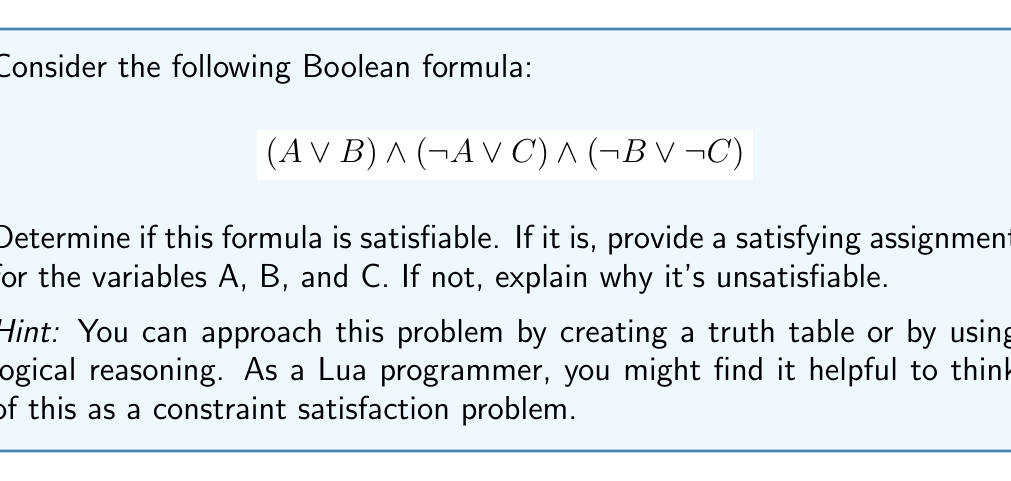Solve this math problem. Let's approach this step-by-step:

1) First, let's break down the formula into its constituent clauses:
   - Clause 1: $(A \lor B)$
   - Clause 2: $(\neg A \lor C)$
   - Clause 3: $(\neg B \lor \neg C)$

2) For the formula to be satisfiable, all these clauses must be true simultaneously.

3) Let's start with Clause 1: $(A \lor B)$
   - This means either A or B (or both) must be true.

4) Now, let's look at Clause 2: $(\neg A \lor C)$
   - This means either A must be false or C must be true (or both).

5) Clause 3: $(\neg B \lor \neg C)$
   - This means either B must be false or C must be false (or both).

6) Let's try to find a satisfying assignment:
   - If we set A = true, then from Clause 2, C must be true.
   - But if C is true, then from Clause 3, B must be false.
   - This assignment (A = true, B = false, C = true) satisfies all clauses.

7) We can verify:
   - $(A \lor B)$ is true because A is true.
   - $(\neg A \lor C)$ is true because C is true.
   - $(\neg B \lor \neg C)$ is true because B is false.

8) Therefore, the formula is satisfiable.

In Lua, you might represent this as:

```lua
A, B, C = true, false, true
assert((A or B) and (not A or C) and (not B or not C))
```

This code would run without raising an error, confirming the satisfiability.
Answer: Satisfiable; A = true, B = false, C = true 